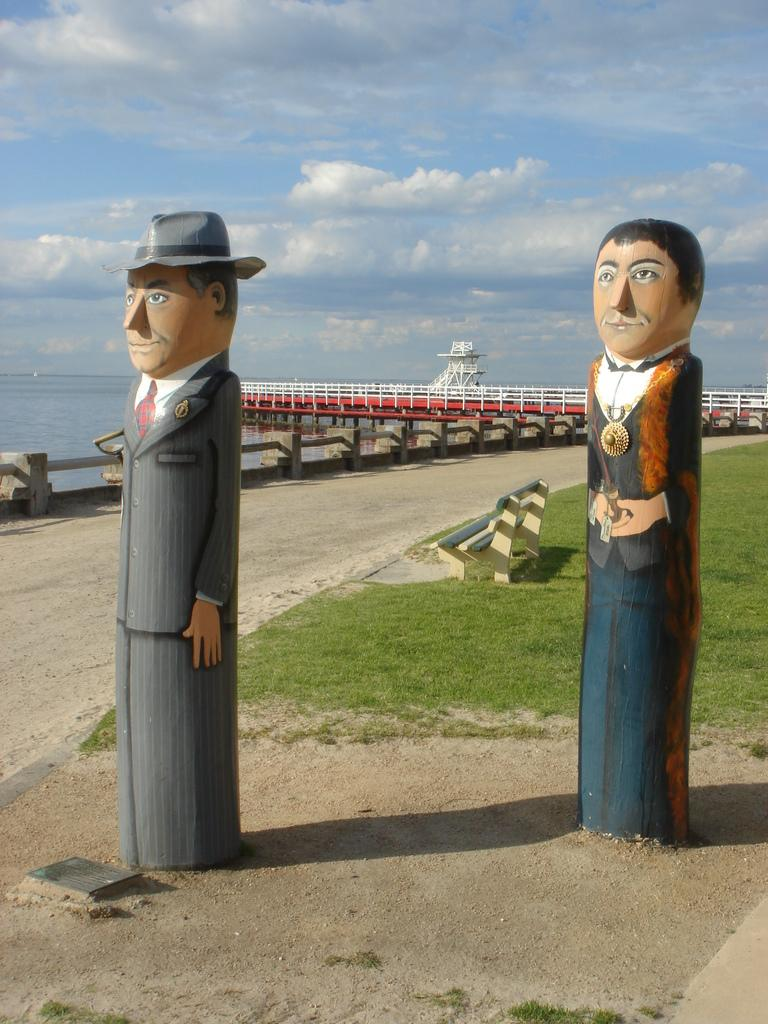What can be found on the ground in the image? There are statues on the ground in the image. What is a piece of furniture that can be seen in the image? There is a bench in the image. What type of architectural feature is present in the image? There is railing in the image. What structure is visible in the image? There is a bridge in the image. What natural element is visible in the image? There is water visible in the image. What is visible in the background of the image? The sky is visible in the background of the image. What can be seen in the sky? There are clouds in the sky. What type of lock is used to secure the frame in the image? There is no lock or frame present in the image. What memory is being captured in the image? The image does not depict a specific memory; it is a scene with statues, a bench, railing, a bridge, water, sky, and clouds. 